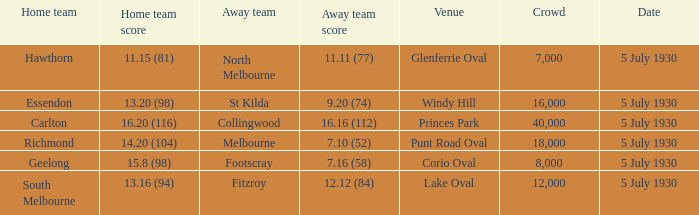At corio oval, who is the away team? Footscray. 